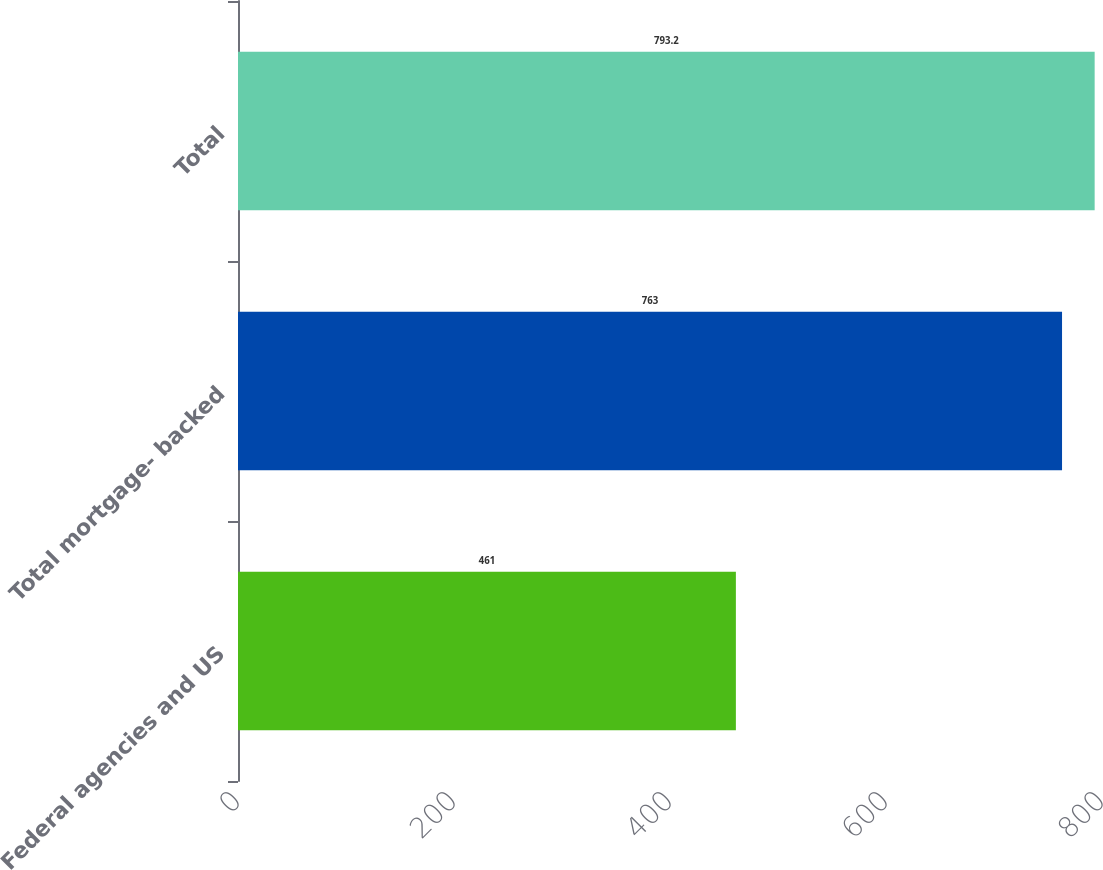<chart> <loc_0><loc_0><loc_500><loc_500><bar_chart><fcel>Federal agencies and US<fcel>Total mortgage- backed<fcel>Total<nl><fcel>461<fcel>763<fcel>793.2<nl></chart> 